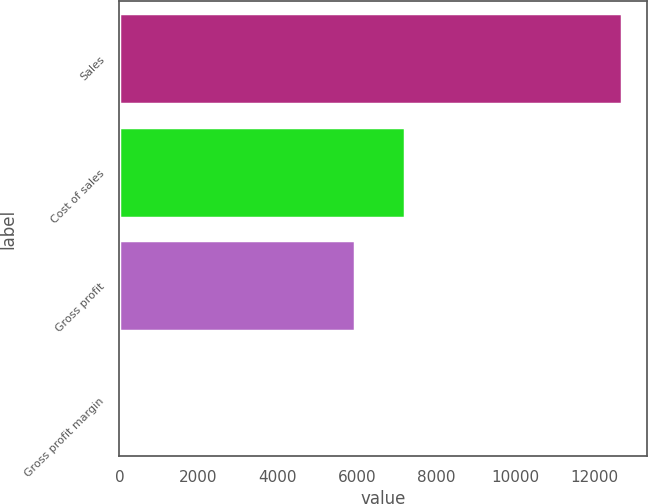Convert chart. <chart><loc_0><loc_0><loc_500><loc_500><bar_chart><fcel>Sales<fcel>Cost of sales<fcel>Gross profit<fcel>Gross profit margin<nl><fcel>12697.5<fcel>7205.27<fcel>5940.2<fcel>46.8<nl></chart> 